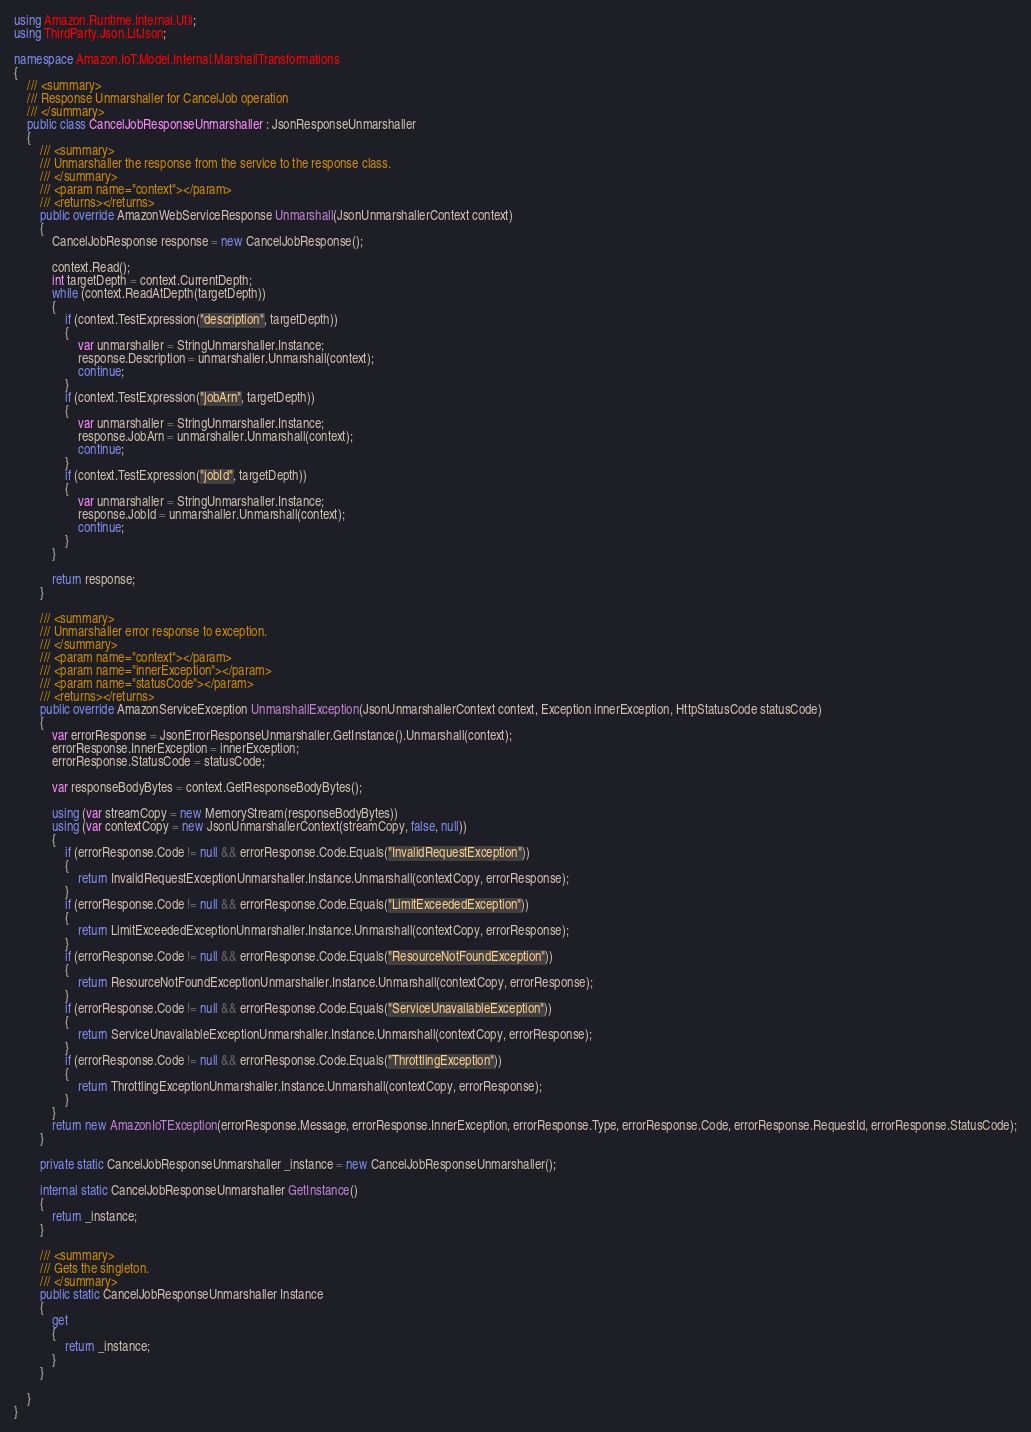Convert code to text. <code><loc_0><loc_0><loc_500><loc_500><_C#_>using Amazon.Runtime.Internal.Util;
using ThirdParty.Json.LitJson;

namespace Amazon.IoT.Model.Internal.MarshallTransformations
{
    /// <summary>
    /// Response Unmarshaller for CancelJob operation
    /// </summary>  
    public class CancelJobResponseUnmarshaller : JsonResponseUnmarshaller
    {
        /// <summary>
        /// Unmarshaller the response from the service to the response class.
        /// </summary>  
        /// <param name="context"></param>
        /// <returns></returns>
        public override AmazonWebServiceResponse Unmarshall(JsonUnmarshallerContext context)
        {
            CancelJobResponse response = new CancelJobResponse();

            context.Read();
            int targetDepth = context.CurrentDepth;
            while (context.ReadAtDepth(targetDepth))
            {
                if (context.TestExpression("description", targetDepth))
                {
                    var unmarshaller = StringUnmarshaller.Instance;
                    response.Description = unmarshaller.Unmarshall(context);
                    continue;
                }
                if (context.TestExpression("jobArn", targetDepth))
                {
                    var unmarshaller = StringUnmarshaller.Instance;
                    response.JobArn = unmarshaller.Unmarshall(context);
                    continue;
                }
                if (context.TestExpression("jobId", targetDepth))
                {
                    var unmarshaller = StringUnmarshaller.Instance;
                    response.JobId = unmarshaller.Unmarshall(context);
                    continue;
                }
            }

            return response;
        }

        /// <summary>
        /// Unmarshaller error response to exception.
        /// </summary>  
        /// <param name="context"></param>
        /// <param name="innerException"></param>
        /// <param name="statusCode"></param>
        /// <returns></returns>
        public override AmazonServiceException UnmarshallException(JsonUnmarshallerContext context, Exception innerException, HttpStatusCode statusCode)
        {
            var errorResponse = JsonErrorResponseUnmarshaller.GetInstance().Unmarshall(context);
            errorResponse.InnerException = innerException;
            errorResponse.StatusCode = statusCode;

            var responseBodyBytes = context.GetResponseBodyBytes();

            using (var streamCopy = new MemoryStream(responseBodyBytes))
            using (var contextCopy = new JsonUnmarshallerContext(streamCopy, false, null))
            {
                if (errorResponse.Code != null && errorResponse.Code.Equals("InvalidRequestException"))
                {
                    return InvalidRequestExceptionUnmarshaller.Instance.Unmarshall(contextCopy, errorResponse);
                }
                if (errorResponse.Code != null && errorResponse.Code.Equals("LimitExceededException"))
                {
                    return LimitExceededExceptionUnmarshaller.Instance.Unmarshall(contextCopy, errorResponse);
                }
                if (errorResponse.Code != null && errorResponse.Code.Equals("ResourceNotFoundException"))
                {
                    return ResourceNotFoundExceptionUnmarshaller.Instance.Unmarshall(contextCopy, errorResponse);
                }
                if (errorResponse.Code != null && errorResponse.Code.Equals("ServiceUnavailableException"))
                {
                    return ServiceUnavailableExceptionUnmarshaller.Instance.Unmarshall(contextCopy, errorResponse);
                }
                if (errorResponse.Code != null && errorResponse.Code.Equals("ThrottlingException"))
                {
                    return ThrottlingExceptionUnmarshaller.Instance.Unmarshall(contextCopy, errorResponse);
                }
            }
            return new AmazonIoTException(errorResponse.Message, errorResponse.InnerException, errorResponse.Type, errorResponse.Code, errorResponse.RequestId, errorResponse.StatusCode);
        }

        private static CancelJobResponseUnmarshaller _instance = new CancelJobResponseUnmarshaller();        

        internal static CancelJobResponseUnmarshaller GetInstance()
        {
            return _instance;
        }

        /// <summary>
        /// Gets the singleton.
        /// </summary>  
        public static CancelJobResponseUnmarshaller Instance
        {
            get
            {
                return _instance;
            }
        }

    }
}</code> 